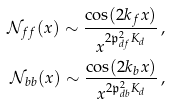<formula> <loc_0><loc_0><loc_500><loc_500>\mathcal { N } _ { f f } ( x ) \sim \frac { \cos ( 2 k _ { f } x ) } { x ^ { 2 \mathfrak { p } _ { d f } ^ { 2 } K _ { d } } } \, , \\ \mathcal { N } _ { b b } ( x ) \sim \frac { \cos ( 2 k _ { b } x ) } { x ^ { 2 \mathfrak { p } _ { d b } ^ { 2 } K _ { d } } } \, ,</formula> 